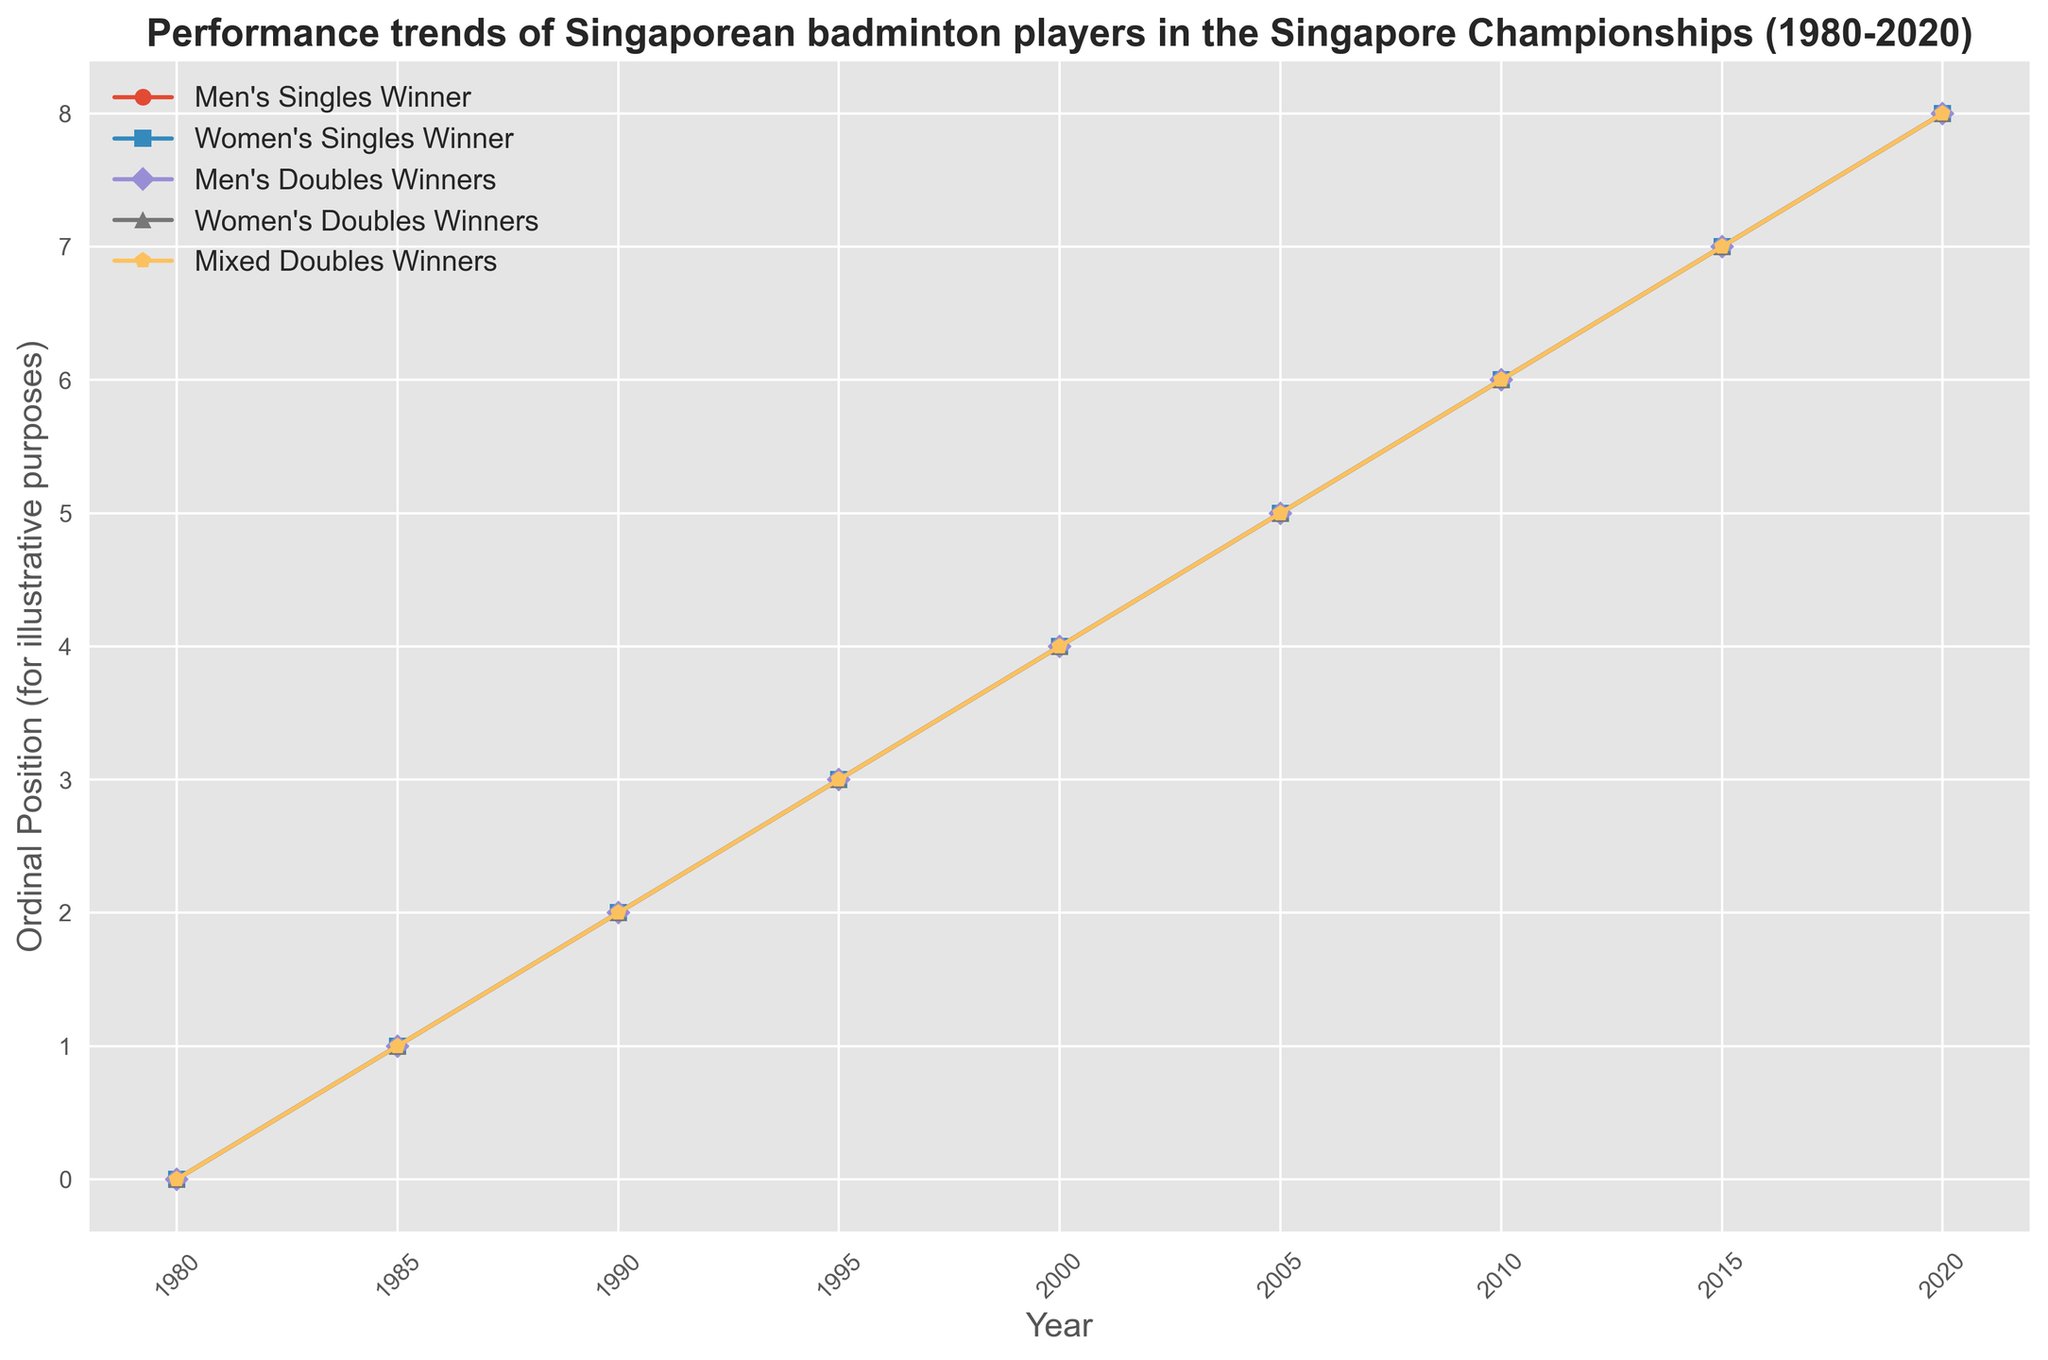What is the general trend of winners in the Women's Singles category from 1980 to 2020? By observing the plot, we can see the data points associated with the Women's Singles category, which use markers that indicate the winners across the years. Since names differ and change over time, it suggests a trend of different winners throughout the time period, indicating no obvious single dominating player.
Answer: Multiple winners Which category shows a consistent pairing of winners over consecutive years? For this, examine each category and look for consecutive data points that show the same winners indicated by the same marker style. Men's Doubles, Women's Doubles, and Mixed Doubles have distinct markers per year, showing no repeated pairs over consecutive years.
Answer: None Which year had Loh Kean Yew winning in multiple categories? Identify the name "Loh Kean Yew" among the markers in different categories and observe the year associated with that player's participation in Men's Singles, Men's Doubles, and potentially other categories. According to the plot, Loh Kean Yew appears in multiple categories in the year 2020.
Answer: 2020 Who won both the Men’s Singles and Men's Doubles in 2005? Look at the plot and examine the corresponding marker styles for Men's Singles and Men's Doubles in 2005. Both categories will point to the player Derek Wong.
Answer: Derek Wong How often did the same player win both the Men's Singles and Men's Doubles categories? Given the plot, we can count the number of times the markers align vertically for these two categories, indicating the same winner. The analysis shows instances such as 1980 (Tan Aik Huang), 1990 (Henry Tan), 1995 (Daniel Goh), 2005 (Derek Wong), 2010 (Ronald Susilo), 2015 (Danny Bawa Chrisnanta), and 2020 (Loh Kean Yew). So, this happens seven times.
Answer: 7 times Which Women's Singles winner also participated in Mixed Doubles the most often? Tracking names in the Women's Singles category and finding overlaps in the Mixed Doubles category determines frequency. Notably, Zhang Beiwen appears multiple times (2010, 2015) in both categories.
Answer: Zhang Beiwen What is the range of years in which the Men's Singles winners varied the most? Observing fluctuations in the marker travels up and down across the years in this category can signify variations in winners. Comparing across spans of years shows significant change between 2000 and 2020, where a variety of names appear, including 2000 (Kenneth Tanow), 2005 (Derek Wong), 2010 (Ronald Susilo), 2015 (Danny Bawa Chrisnanta), and 2020 (Loh Kean Yew).
Answer: 2000-2020 Who are the Mixed Doubles winners with the same female participant in consecutive years? Check the plot for recurring names in the Mixed Doubles category with consistency in the female partner. Notably, Fu Mingtian is seen consistently in 2005 (Desmond Tan/Fu Mingtian) across consecutive years.
Answer: Fu Mingtian How many unique winners are shown for each category over the entire period? Counting distinct names in each category's sequence of markers for the visualization, estimate uniqueness. A detailed count for each will provide, i.e., Men's Singles (8), Women's Singles (8), Men’s Doubles (8 pairs), Women’s Doubles (8 pairs), and Mixed Doubles (9 pairs).
Answer: Men's Singles (8), Women's Singles (8), Men’s Doubles (8), Women’s Doubles (8), Mixed Doubles (9) 